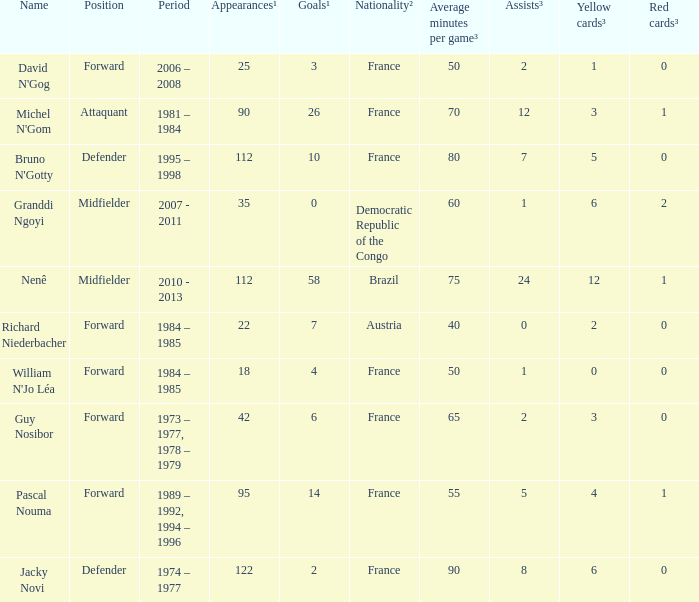List the number of active years for attaquant. 1981 – 1984. 